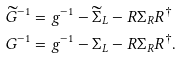Convert formula to latex. <formula><loc_0><loc_0><loc_500><loc_500>\widetilde { G } ^ { - 1 } & = g ^ { - 1 } - \widetilde { \Sigma } _ { L } - R \Sigma _ { R } R ^ { \dag } \\ G ^ { - 1 } & = g ^ { - 1 } - \Sigma _ { L } - R \Sigma _ { R } R ^ { \dag } .</formula> 